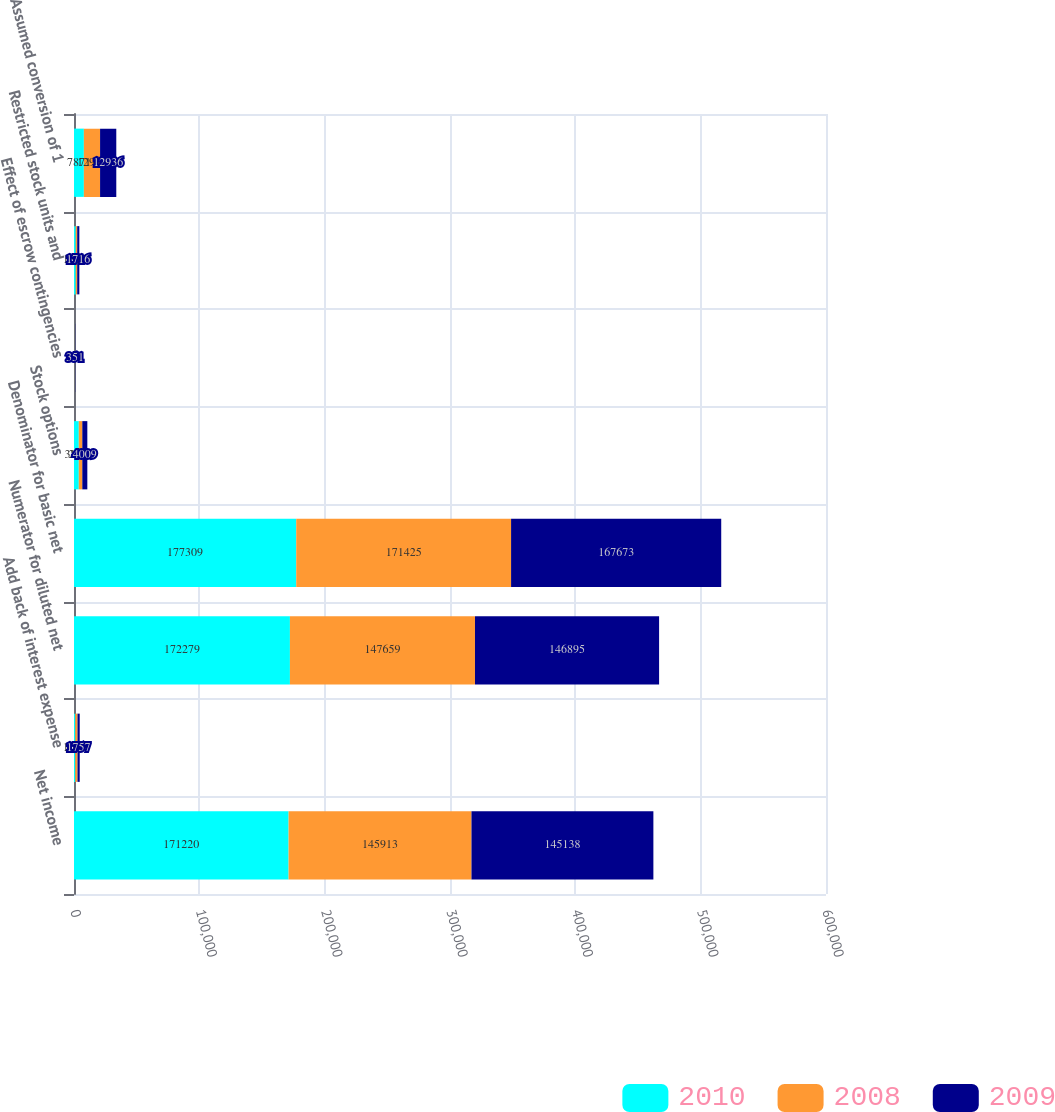Convert chart. <chart><loc_0><loc_0><loc_500><loc_500><stacked_bar_chart><ecel><fcel>Net income<fcel>Add back of interest expense<fcel>Numerator for diluted net<fcel>Denominator for basic net<fcel>Stock options<fcel>Effect of escrow contingencies<fcel>Restricted stock units and<fcel>Assumed conversion of 1<nl><fcel>2010<fcel>171220<fcel>1059<fcel>172279<fcel>177309<fcel>3821<fcel>254<fcel>1395<fcel>7871<nl><fcel>2008<fcel>145913<fcel>1746<fcel>147659<fcel>171425<fcel>2805<fcel>342<fcel>1153<fcel>12933<nl><fcel>2009<fcel>145138<fcel>1757<fcel>146895<fcel>167673<fcel>4009<fcel>351<fcel>1716<fcel>12936<nl></chart> 